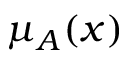<formula> <loc_0><loc_0><loc_500><loc_500>\mu _ { A } ( x )</formula> 